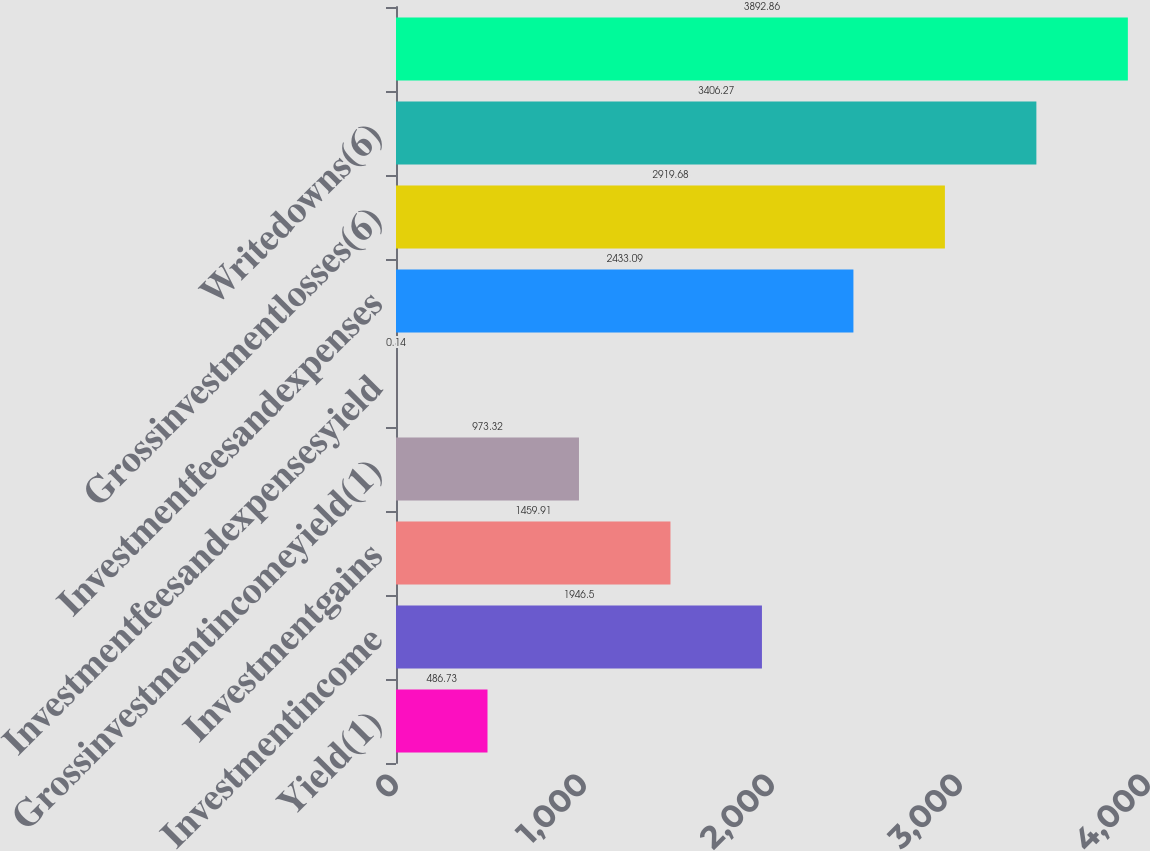Convert chart. <chart><loc_0><loc_0><loc_500><loc_500><bar_chart><fcel>Yield(1)<fcel>Investmentincome<fcel>Investmentgains<fcel>Grossinvestmentincomeyield(1)<fcel>Investmentfeesandexpensesyield<fcel>Investmentfeesandexpenses<fcel>Grossinvestmentlosses(6)<fcel>Writedowns(6)<fcel>Unnamed: 8<nl><fcel>486.73<fcel>1946.5<fcel>1459.91<fcel>973.32<fcel>0.14<fcel>2433.09<fcel>2919.68<fcel>3406.27<fcel>3892.86<nl></chart> 